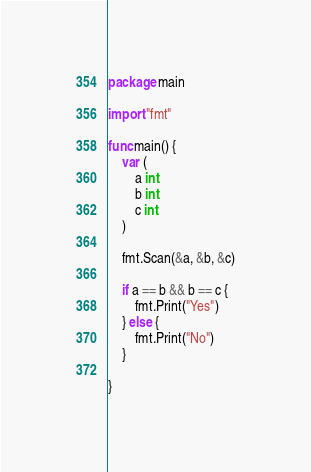Convert code to text. <code><loc_0><loc_0><loc_500><loc_500><_Go_>package main

import "fmt"

func main() {
	var (
		a int
		b int
		c int
	)

	fmt.Scan(&a, &b, &c)

	if a == b && b == c {
		fmt.Print("Yes")
	} else {
		fmt.Print("No")
	}

}
</code> 